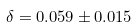Convert formula to latex. <formula><loc_0><loc_0><loc_500><loc_500>\delta = 0 . 0 5 9 \pm 0 . 0 1 5</formula> 